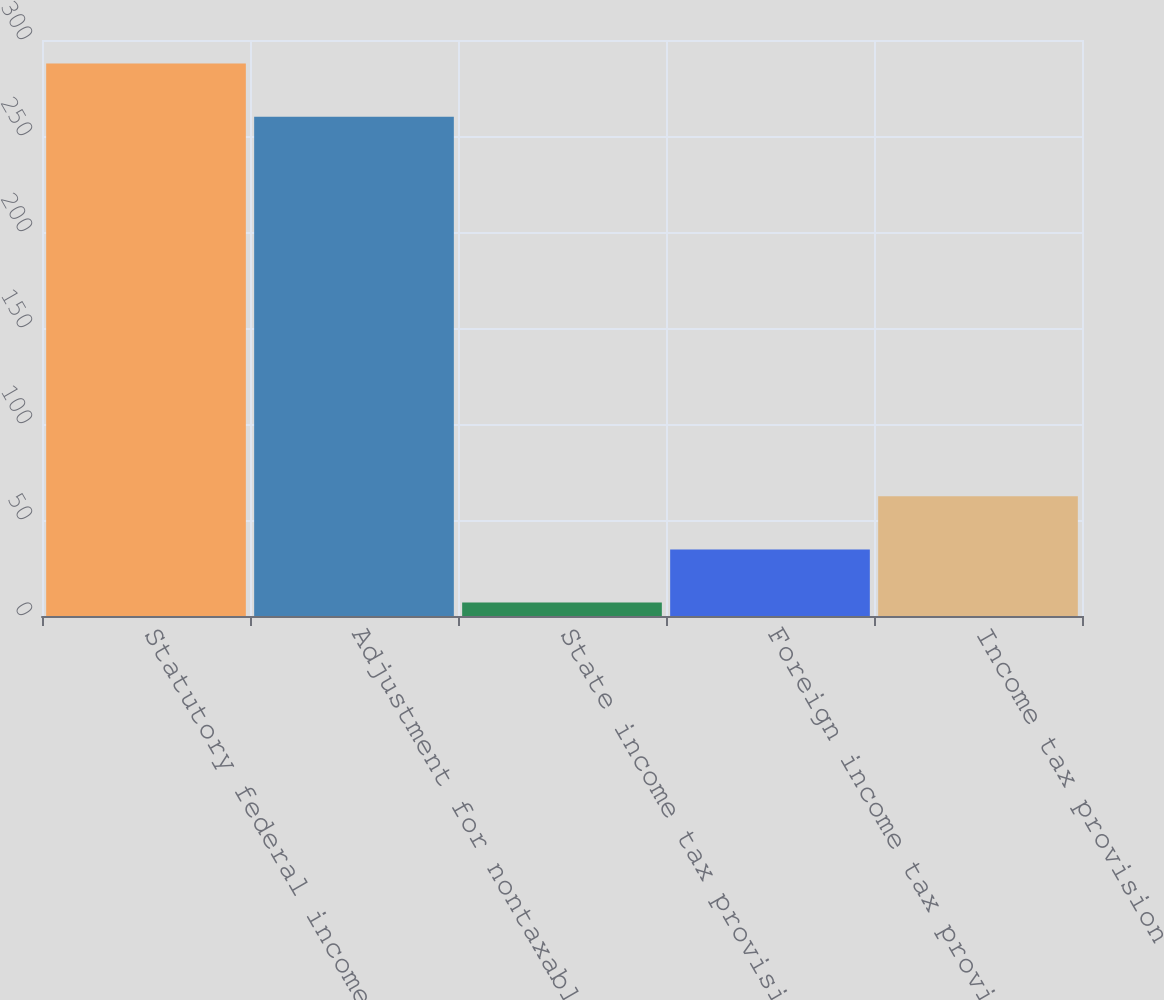Convert chart to OTSL. <chart><loc_0><loc_0><loc_500><loc_500><bar_chart><fcel>Statutory federal income tax<fcel>Adjustment for nontaxable<fcel>State income tax provision net<fcel>Foreign income tax provision<fcel>Income tax provision<nl><fcel>287.7<fcel>260<fcel>7<fcel>34.7<fcel>62.4<nl></chart> 